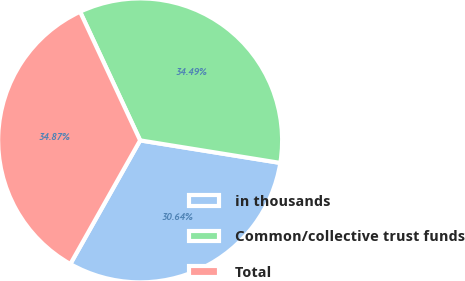<chart> <loc_0><loc_0><loc_500><loc_500><pie_chart><fcel>in thousands<fcel>Common/collective trust funds<fcel>Total<nl><fcel>30.64%<fcel>34.49%<fcel>34.87%<nl></chart> 